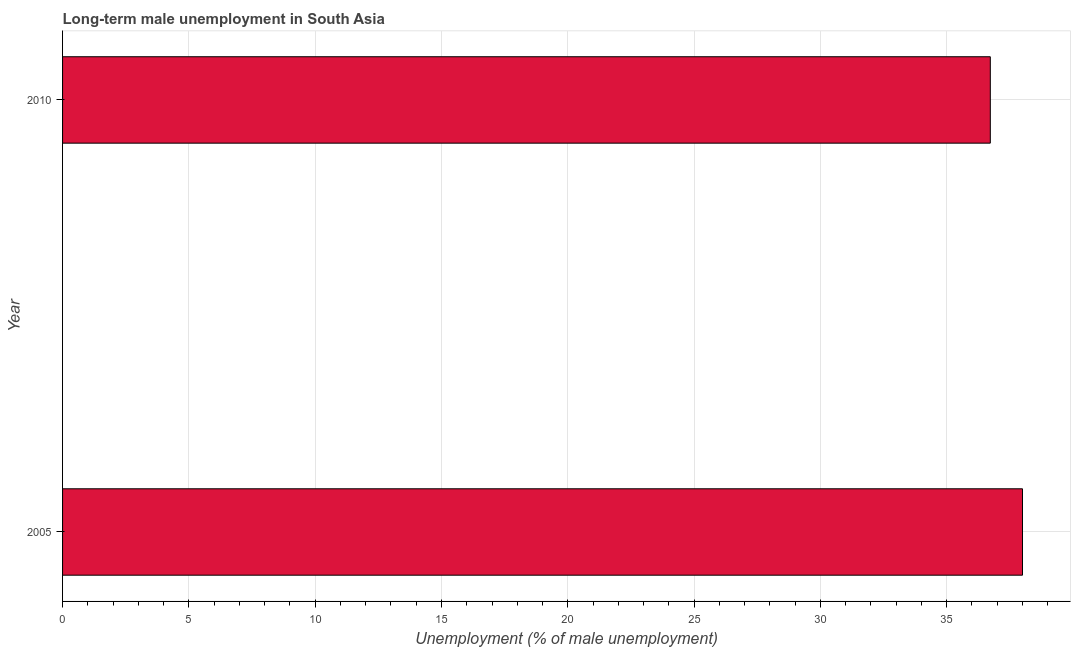Does the graph contain any zero values?
Your response must be concise. No. What is the title of the graph?
Offer a terse response. Long-term male unemployment in South Asia. What is the label or title of the X-axis?
Give a very brief answer. Unemployment (% of male unemployment). What is the label or title of the Y-axis?
Keep it short and to the point. Year. What is the long-term male unemployment in 2005?
Keep it short and to the point. 38. Across all years, what is the minimum long-term male unemployment?
Your answer should be compact. 36.73. In which year was the long-term male unemployment minimum?
Offer a very short reply. 2010. What is the sum of the long-term male unemployment?
Keep it short and to the point. 74.73. What is the difference between the long-term male unemployment in 2005 and 2010?
Your answer should be very brief. 1.27. What is the average long-term male unemployment per year?
Provide a short and direct response. 37.36. What is the median long-term male unemployment?
Your response must be concise. 37.36. In how many years, is the long-term male unemployment greater than 32 %?
Your answer should be very brief. 2. What is the ratio of the long-term male unemployment in 2005 to that in 2010?
Your response must be concise. 1.03. Is the long-term male unemployment in 2005 less than that in 2010?
Your response must be concise. No. How many bars are there?
Keep it short and to the point. 2. Are all the bars in the graph horizontal?
Offer a very short reply. Yes. How many years are there in the graph?
Your response must be concise. 2. What is the Unemployment (% of male unemployment) of 2010?
Your response must be concise. 36.73. What is the difference between the Unemployment (% of male unemployment) in 2005 and 2010?
Provide a short and direct response. 1.27. What is the ratio of the Unemployment (% of male unemployment) in 2005 to that in 2010?
Keep it short and to the point. 1.03. 